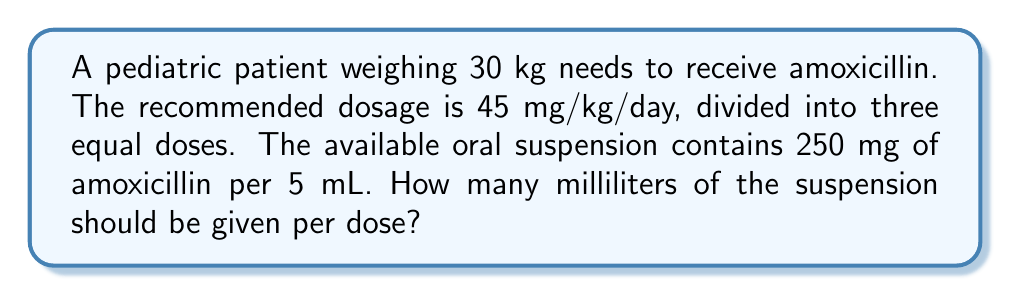Give your solution to this math problem. 1. Calculate the total daily dose:
   $$ \text{Daily dose} = 45 \text{ mg/kg/day} \times 30 \text{ kg} = 1350 \text{ mg/day} $$

2. Divide the daily dose into three equal doses:
   $$ \text{Dose per administration} = \frac{1350 \text{ mg}}{3} = 450 \text{ mg} $$

3. Set up a proportion to convert mg to mL:
   $$ \frac{250 \text{ mg}}{5 \text{ mL}} = \frac{450 \text{ mg}}{x \text{ mL}} $$

4. Cross multiply:
   $$ 250x = 5 \times 450 $$

5. Solve for $x$:
   $$ x = \frac{5 \times 450}{250} = \frac{2250}{250} = 9 \text{ mL} $$
Answer: 9 mL 